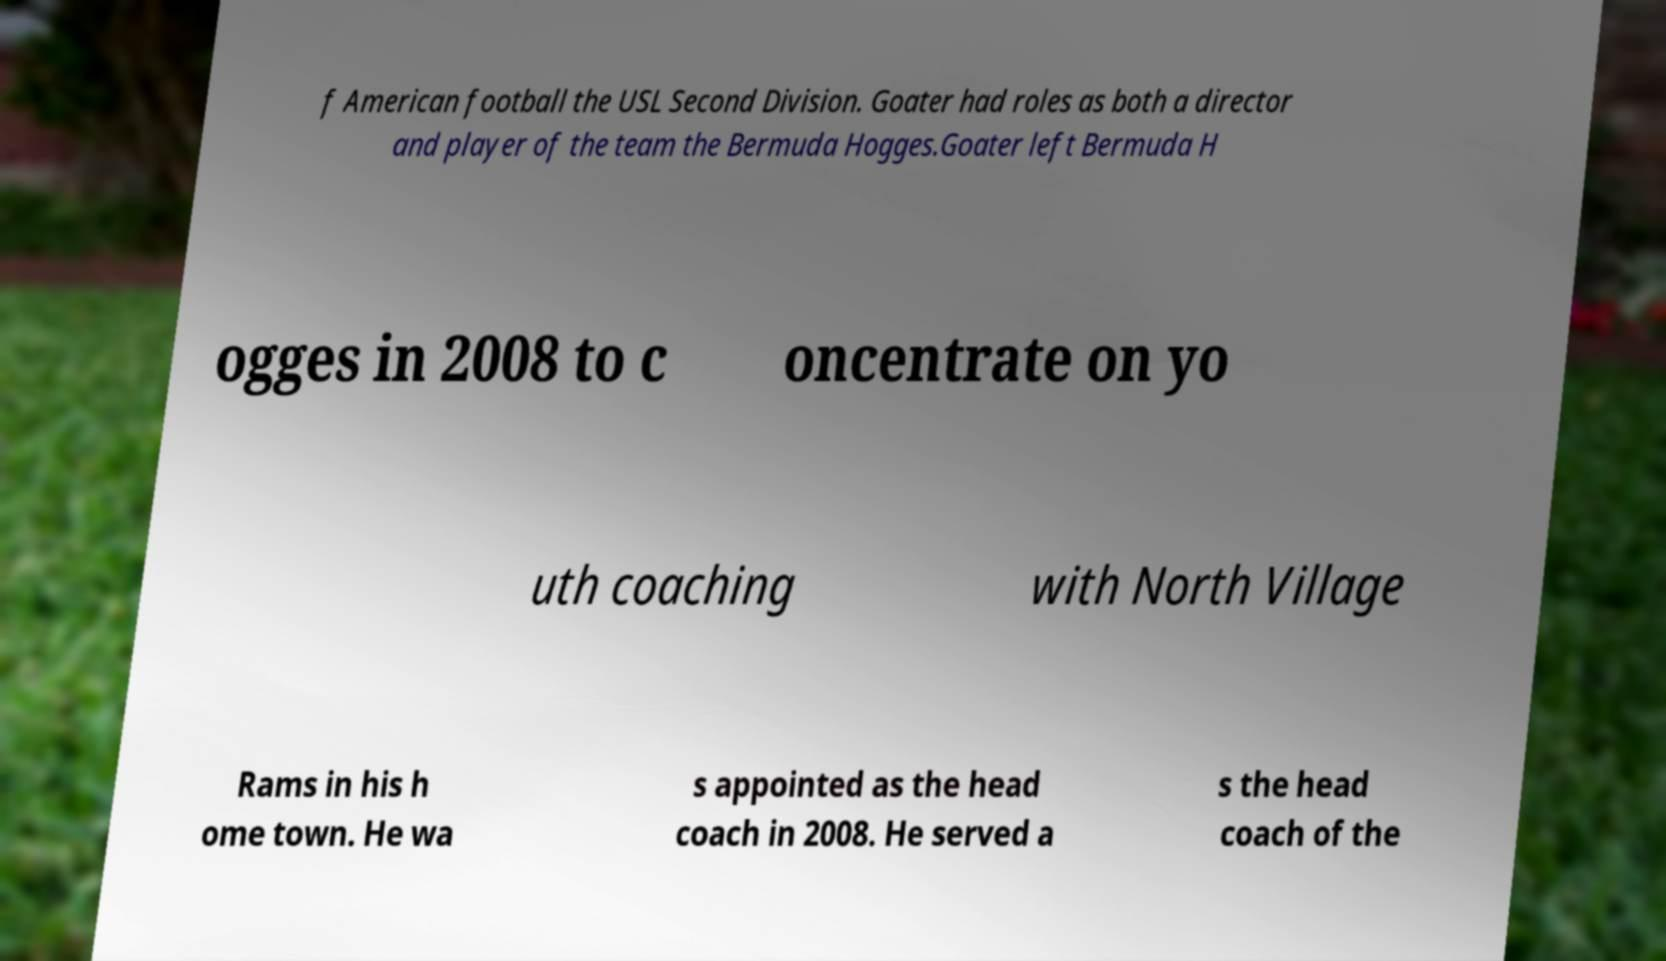Can you read and provide the text displayed in the image?This photo seems to have some interesting text. Can you extract and type it out for me? f American football the USL Second Division. Goater had roles as both a director and player of the team the Bermuda Hogges.Goater left Bermuda H ogges in 2008 to c oncentrate on yo uth coaching with North Village Rams in his h ome town. He wa s appointed as the head coach in 2008. He served a s the head coach of the 